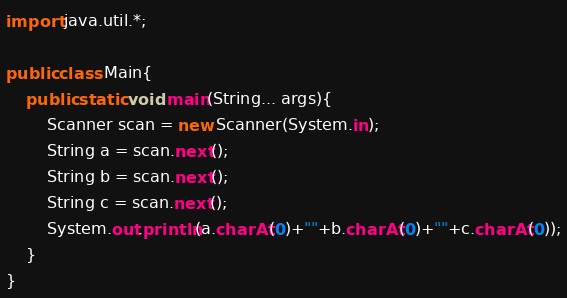Convert code to text. <code><loc_0><loc_0><loc_500><loc_500><_Java_>import java.util.*;

public class Main{
    public static void main(String... args){
        Scanner scan = new Scanner(System.in);
        String a = scan.next();
        String b = scan.next();
        String c = scan.next();
        System.out.println(a.charAt(0)+""+b.charAt(0)+""+c.charAt(0));
    }
}</code> 